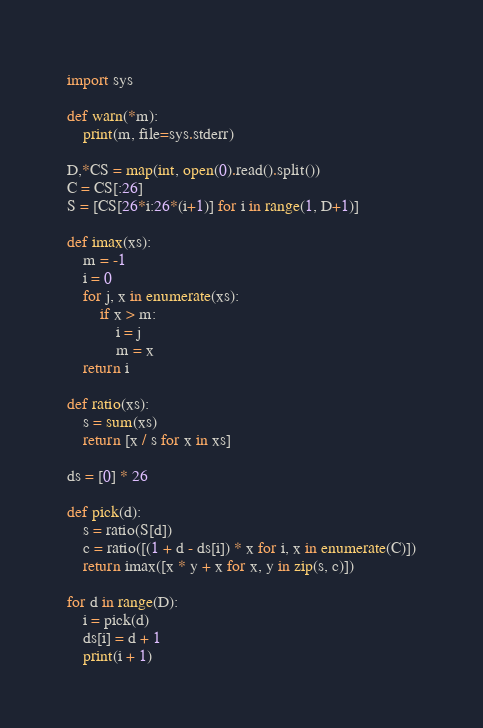<code> <loc_0><loc_0><loc_500><loc_500><_Python_>import sys

def warn(*m):
    print(m, file=sys.stderr)

D,*CS = map(int, open(0).read().split())
C = CS[:26]
S = [CS[26*i:26*(i+1)] for i in range(1, D+1)]

def imax(xs):
    m = -1
    i = 0
    for j, x in enumerate(xs):
        if x > m:
            i = j
            m = x
    return i

def ratio(xs):
    s = sum(xs)
    return [x / s for x in xs]

ds = [0] * 26

def pick(d):
    s = ratio(S[d])
    c = ratio([(1 + d - ds[i]) * x for i, x in enumerate(C)])
    return imax([x * y + x for x, y in zip(s, c)])

for d in range(D):
    i = pick(d)
    ds[i] = d + 1
    print(i + 1)
</code> 